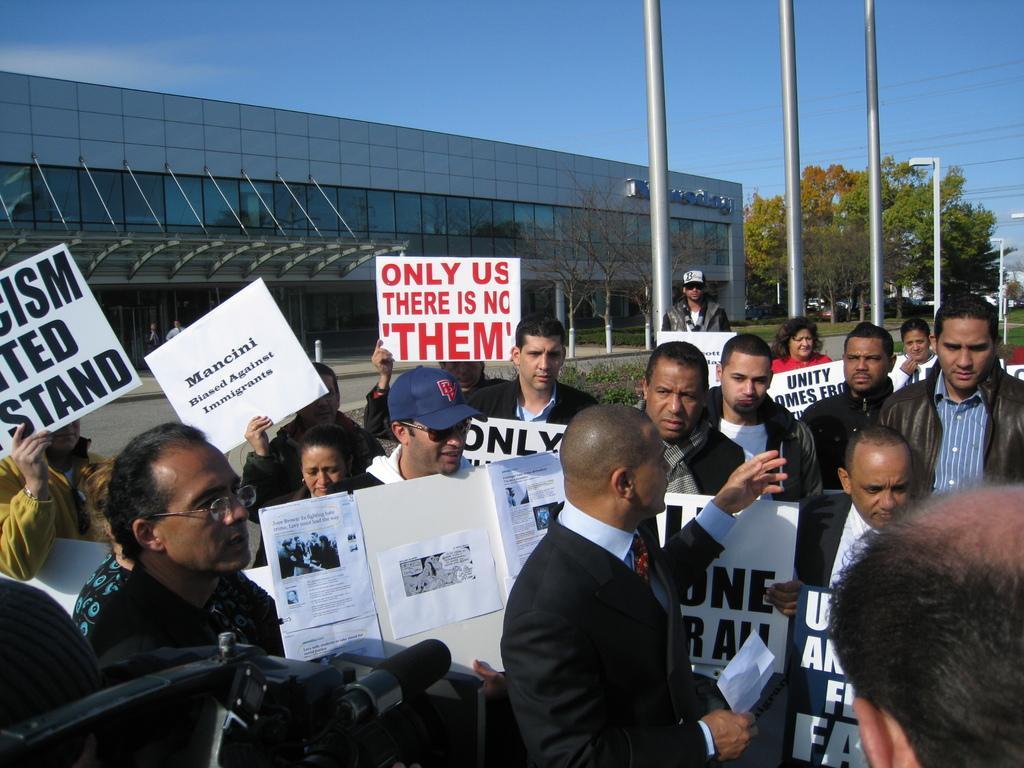Could you give a brief overview of what you see in this image? In this image there are some persons standing and holding some written boards in their hands as we can see at bottom of this image. There are some trees at right side of this image and there are some poles are at right side of this image. There is a building at left side of this image and there is a sky at top of this image and there are some cameras at bottom left corner of this image. 